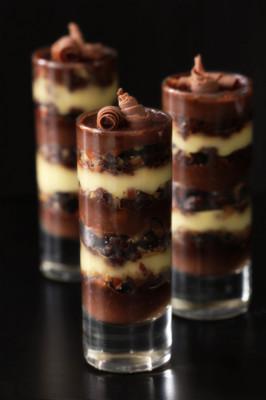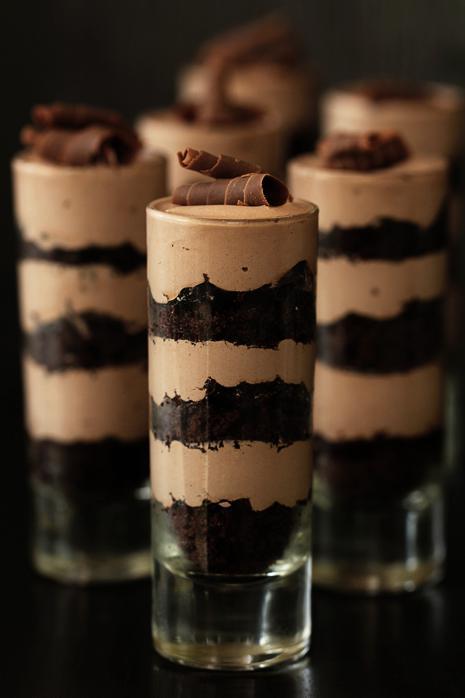The first image is the image on the left, the second image is the image on the right. Assess this claim about the two images: "An image shows at least four individual layered desserts served in slender cylindrical glasses.". Correct or not? Answer yes or no. Yes. The first image is the image on the left, the second image is the image on the right. Assess this claim about the two images: "Each image shows at least three individual layered desserts, one at the front and others behind it, made in clear glasses with a garnished top.". Correct or not? Answer yes or no. Yes. 